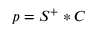<formula> <loc_0><loc_0><loc_500><loc_500>p = { { S } ^ { + } } * C</formula> 